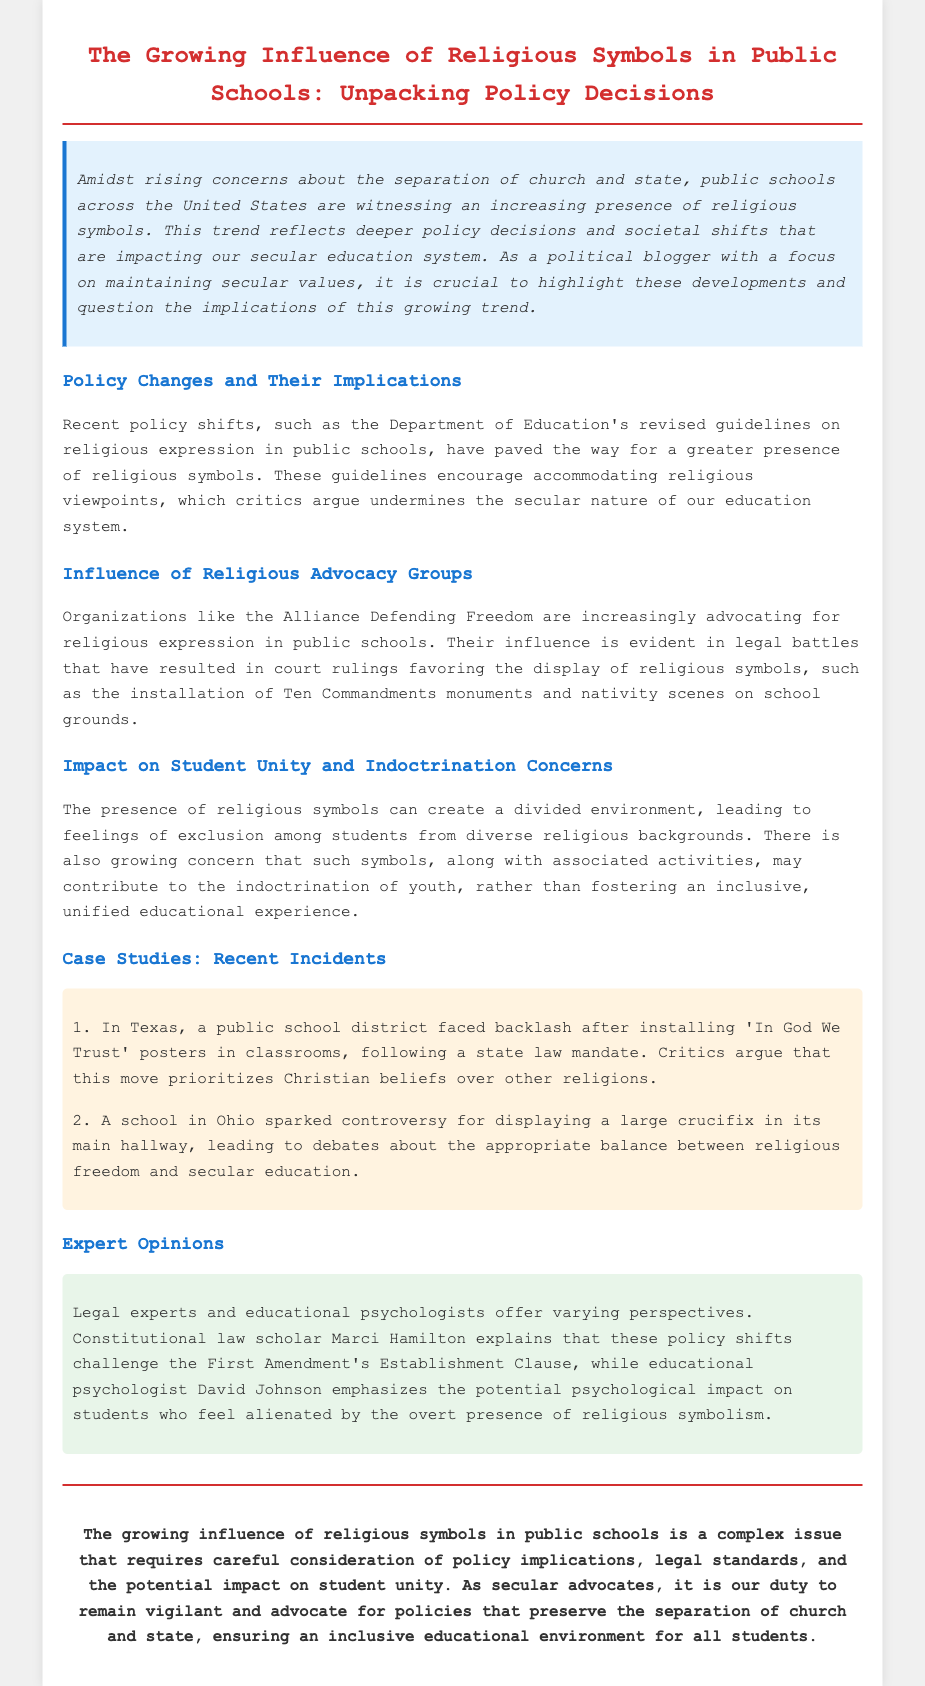What is the title of the press release? The title is stated at the beginning of the document and summarizes the main topic.
Answer: The Growing Influence of Religious Symbols in Public Schools: Unpacking Policy Decisions What organizations are mentioned as advocating for religious expression in public schools? The document specifically names an organization that promotes religious viewpoints in schools within a section dedicated to its influence.
Answer: Alliance Defending Freedom What state faced backlash for 'In God We Trust' posters? The document provides specific information about recent incidents related to religious symbols in public schools, including the state implicated in the controversy.
Answer: Texas Who explained the challenge to the First Amendment's Establishment Clause? The document cites an expert opinion regarding legal perspectives on policy shifts, specifically identifying the individual providing insight.
Answer: Marci Hamilton What does the research suggest happens to students feeling alienated by religious symbolism? The document discusses the implications of religious symbols in schools, particularly the psychological impact on students.
Answer: Potential psychological impact What type of environment can the presence of religious symbols create? The document highlights concerns regarding the social environment in schools due to religious symbols and their implications on student experiences.
Answer: Divided What is the purpose of the press release? The document makes clear the overarching goal of presenting the issue of religious symbols in public schools as it relates to secular advocacy.
Answer: Advocate for policies that preserve the separation of church and state 